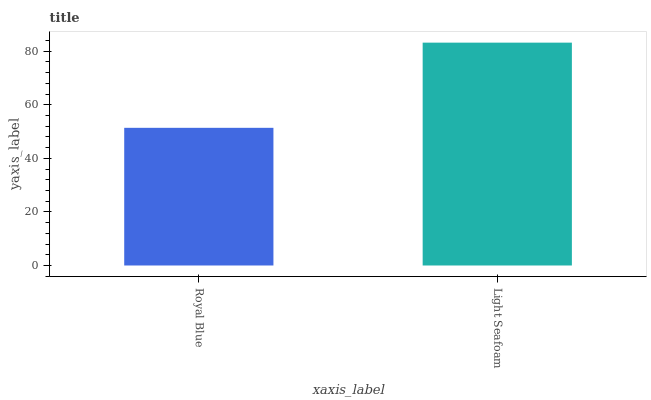Is Royal Blue the minimum?
Answer yes or no. Yes. Is Light Seafoam the maximum?
Answer yes or no. Yes. Is Light Seafoam the minimum?
Answer yes or no. No. Is Light Seafoam greater than Royal Blue?
Answer yes or no. Yes. Is Royal Blue less than Light Seafoam?
Answer yes or no. Yes. Is Royal Blue greater than Light Seafoam?
Answer yes or no. No. Is Light Seafoam less than Royal Blue?
Answer yes or no. No. Is Light Seafoam the high median?
Answer yes or no. Yes. Is Royal Blue the low median?
Answer yes or no. Yes. Is Royal Blue the high median?
Answer yes or no. No. Is Light Seafoam the low median?
Answer yes or no. No. 